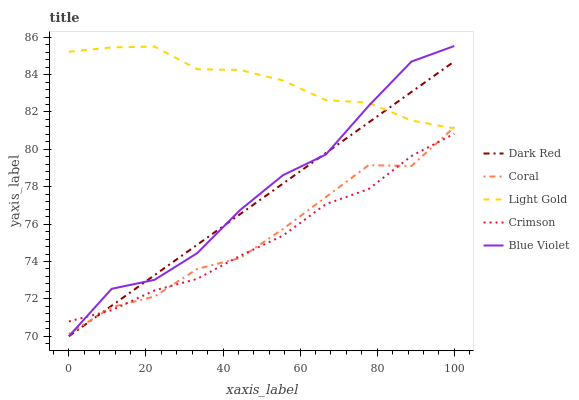Does Dark Red have the minimum area under the curve?
Answer yes or no. No. Does Dark Red have the maximum area under the curve?
Answer yes or no. No. Is Coral the smoothest?
Answer yes or no. No. Is Coral the roughest?
Answer yes or no. No. Does Coral have the lowest value?
Answer yes or no. No. Does Dark Red have the highest value?
Answer yes or no. No. Is Crimson less than Light Gold?
Answer yes or no. Yes. Is Light Gold greater than Crimson?
Answer yes or no. Yes. Does Crimson intersect Light Gold?
Answer yes or no. No. 